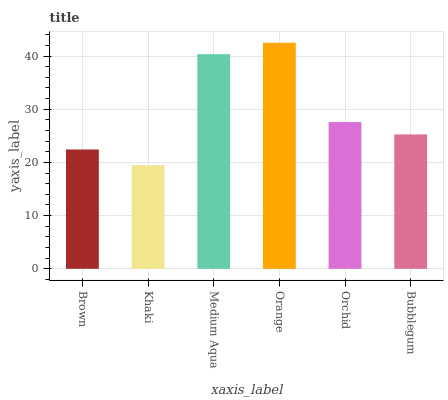Is Khaki the minimum?
Answer yes or no. Yes. Is Orange the maximum?
Answer yes or no. Yes. Is Medium Aqua the minimum?
Answer yes or no. No. Is Medium Aqua the maximum?
Answer yes or no. No. Is Medium Aqua greater than Khaki?
Answer yes or no. Yes. Is Khaki less than Medium Aqua?
Answer yes or no. Yes. Is Khaki greater than Medium Aqua?
Answer yes or no. No. Is Medium Aqua less than Khaki?
Answer yes or no. No. Is Orchid the high median?
Answer yes or no. Yes. Is Bubblegum the low median?
Answer yes or no. Yes. Is Brown the high median?
Answer yes or no. No. Is Medium Aqua the low median?
Answer yes or no. No. 